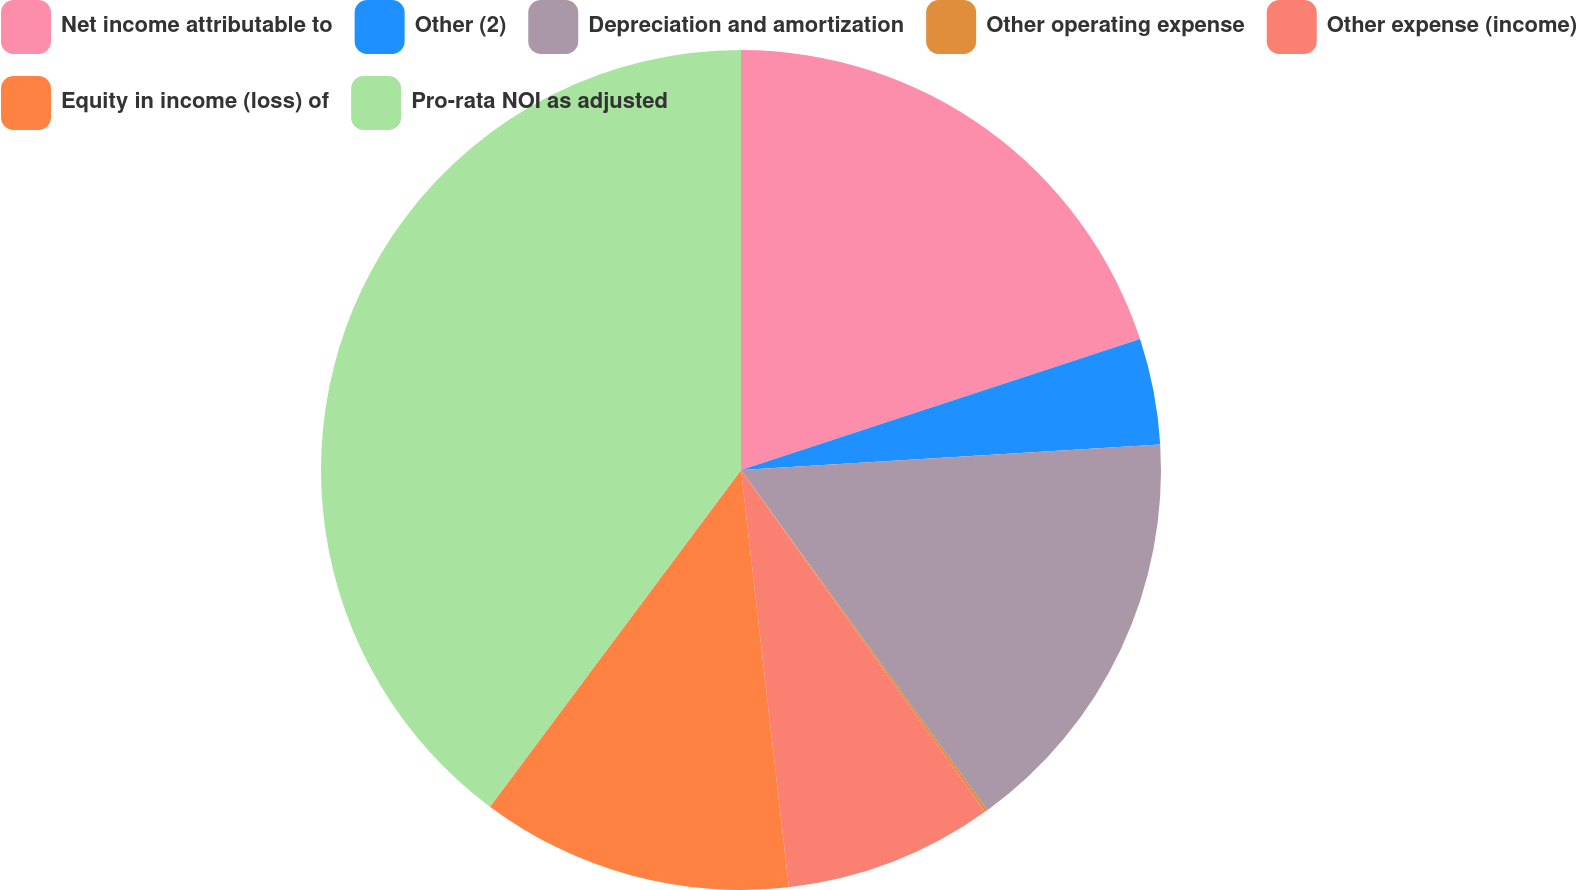<chart> <loc_0><loc_0><loc_500><loc_500><pie_chart><fcel>Net income attributable to<fcel>Other (2)<fcel>Depreciation and amortization<fcel>Other operating expense<fcel>Other expense (income)<fcel>Equity in income (loss) of<fcel>Pro-rata NOI as adjusted<nl><fcel>19.96%<fcel>4.08%<fcel>15.99%<fcel>0.11%<fcel>8.05%<fcel>12.02%<fcel>39.81%<nl></chart> 